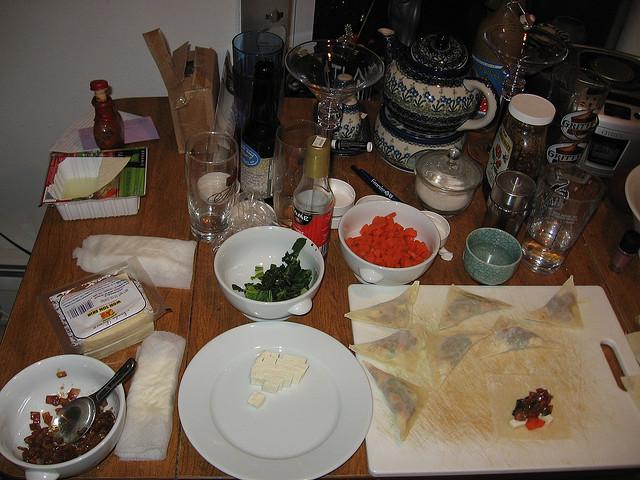Are the drinking glasses full or empty?
Concise answer only. Empty. How many glasses are on the table?
Give a very brief answer. 6. Is the table cluttered?
Short answer required. Yes. What is in the bowl?
Short answer required. Carrots. How many kind of spice is there?
Quick response, please. 4. 